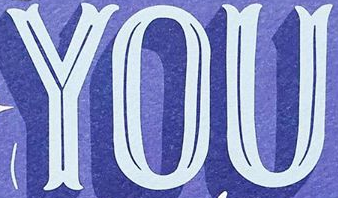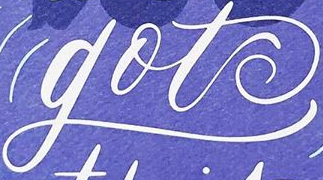What words are shown in these images in order, separated by a semicolon? YOU; got 